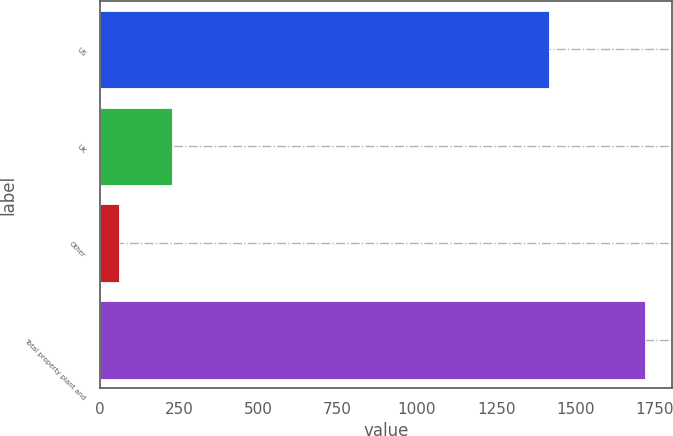<chart> <loc_0><loc_0><loc_500><loc_500><bar_chart><fcel>US<fcel>UK<fcel>Other<fcel>Total property plant and<nl><fcel>1417.8<fcel>227.12<fcel>61.4<fcel>1718.6<nl></chart> 